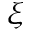Convert formula to latex. <formula><loc_0><loc_0><loc_500><loc_500>\xi</formula> 